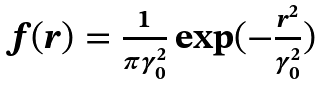<formula> <loc_0><loc_0><loc_500><loc_500>\begin{array} { c } f ( r ) = \frac { 1 } { \pi \gamma _ { 0 } ^ { 2 } } \exp ( - \frac { r ^ { 2 } } { \gamma _ { 0 } ^ { 2 } } ) \end{array}</formula> 